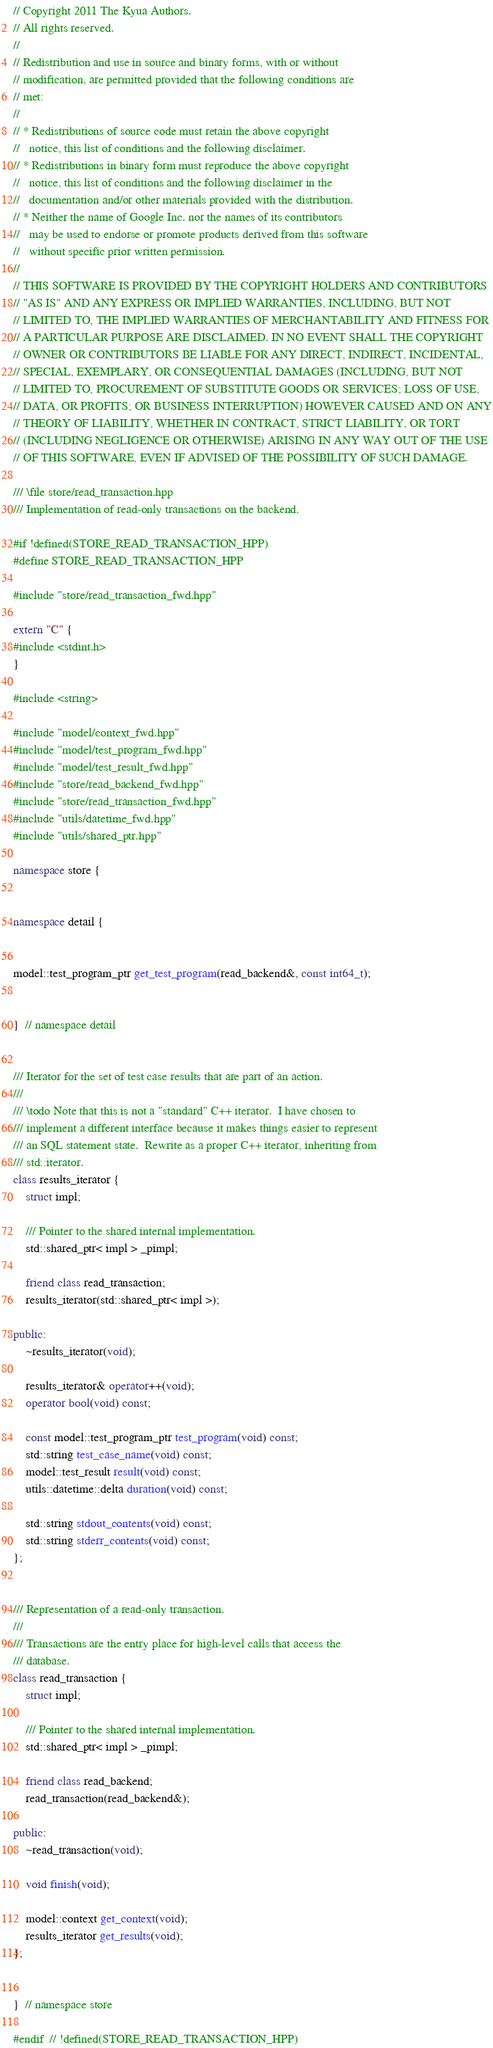Convert code to text. <code><loc_0><loc_0><loc_500><loc_500><_C++_>// Copyright 2011 The Kyua Authors.
// All rights reserved.
//
// Redistribution and use in source and binary forms, with or without
// modification, are permitted provided that the following conditions are
// met:
//
// * Redistributions of source code must retain the above copyright
//   notice, this list of conditions and the following disclaimer.
// * Redistributions in binary form must reproduce the above copyright
//   notice, this list of conditions and the following disclaimer in the
//   documentation and/or other materials provided with the distribution.
// * Neither the name of Google Inc. nor the names of its contributors
//   may be used to endorse or promote products derived from this software
//   without specific prior written permission.
//
// THIS SOFTWARE IS PROVIDED BY THE COPYRIGHT HOLDERS AND CONTRIBUTORS
// "AS IS" AND ANY EXPRESS OR IMPLIED WARRANTIES, INCLUDING, BUT NOT
// LIMITED TO, THE IMPLIED WARRANTIES OF MERCHANTABILITY AND FITNESS FOR
// A PARTICULAR PURPOSE ARE DISCLAIMED. IN NO EVENT SHALL THE COPYRIGHT
// OWNER OR CONTRIBUTORS BE LIABLE FOR ANY DIRECT, INDIRECT, INCIDENTAL,
// SPECIAL, EXEMPLARY, OR CONSEQUENTIAL DAMAGES (INCLUDING, BUT NOT
// LIMITED TO, PROCUREMENT OF SUBSTITUTE GOODS OR SERVICES; LOSS OF USE,
// DATA, OR PROFITS; OR BUSINESS INTERRUPTION) HOWEVER CAUSED AND ON ANY
// THEORY OF LIABILITY, WHETHER IN CONTRACT, STRICT LIABILITY, OR TORT
// (INCLUDING NEGLIGENCE OR OTHERWISE) ARISING IN ANY WAY OUT OF THE USE
// OF THIS SOFTWARE, EVEN IF ADVISED OF THE POSSIBILITY OF SUCH DAMAGE.

/// \file store/read_transaction.hpp
/// Implementation of read-only transactions on the backend.

#if !defined(STORE_READ_TRANSACTION_HPP)
#define STORE_READ_TRANSACTION_HPP

#include "store/read_transaction_fwd.hpp"

extern "C" {
#include <stdint.h>
}

#include <string>

#include "model/context_fwd.hpp"
#include "model/test_program_fwd.hpp"
#include "model/test_result_fwd.hpp"
#include "store/read_backend_fwd.hpp"
#include "store/read_transaction_fwd.hpp"
#include "utils/datetime_fwd.hpp"
#include "utils/shared_ptr.hpp"

namespace store {


namespace detail {


model::test_program_ptr get_test_program(read_backend&, const int64_t);


}  // namespace detail


/// Iterator for the set of test case results that are part of an action.
///
/// \todo Note that this is not a "standard" C++ iterator.  I have chosen to
/// implement a different interface because it makes things easier to represent
/// an SQL statement state.  Rewrite as a proper C++ iterator, inheriting from
/// std::iterator.
class results_iterator {
    struct impl;

    /// Pointer to the shared internal implementation.
    std::shared_ptr< impl > _pimpl;

    friend class read_transaction;
    results_iterator(std::shared_ptr< impl >);

public:
    ~results_iterator(void);

    results_iterator& operator++(void);
    operator bool(void) const;

    const model::test_program_ptr test_program(void) const;
    std::string test_case_name(void) const;
    model::test_result result(void) const;
    utils::datetime::delta duration(void) const;

    std::string stdout_contents(void) const;
    std::string stderr_contents(void) const;
};


/// Representation of a read-only transaction.
///
/// Transactions are the entry place for high-level calls that access the
/// database.
class read_transaction {
    struct impl;

    /// Pointer to the shared internal implementation.
    std::shared_ptr< impl > _pimpl;

    friend class read_backend;
    read_transaction(read_backend&);

public:
    ~read_transaction(void);

    void finish(void);

    model::context get_context(void);
    results_iterator get_results(void);
};


}  // namespace store

#endif  // !defined(STORE_READ_TRANSACTION_HPP)
</code> 